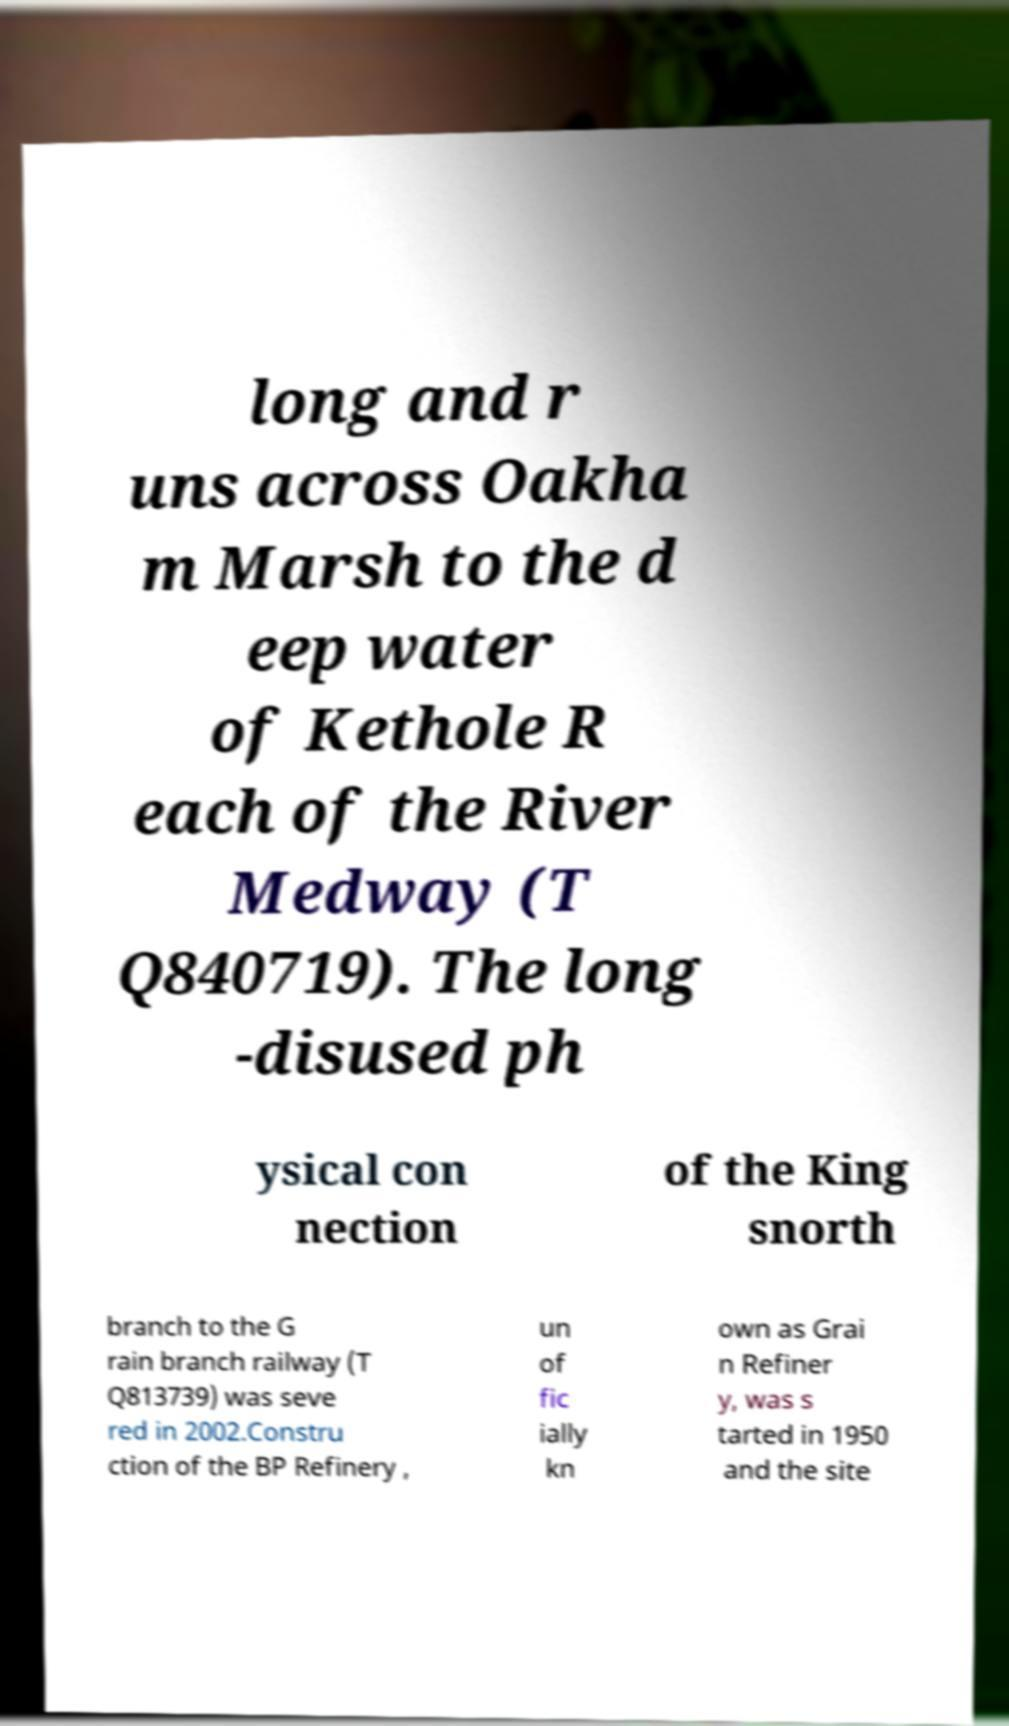Could you extract and type out the text from this image? long and r uns across Oakha m Marsh to the d eep water of Kethole R each of the River Medway (T Q840719). The long -disused ph ysical con nection of the King snorth branch to the G rain branch railway (T Q813739) was seve red in 2002.Constru ction of the BP Refinery , un of fic ially kn own as Grai n Refiner y, was s tarted in 1950 and the site 